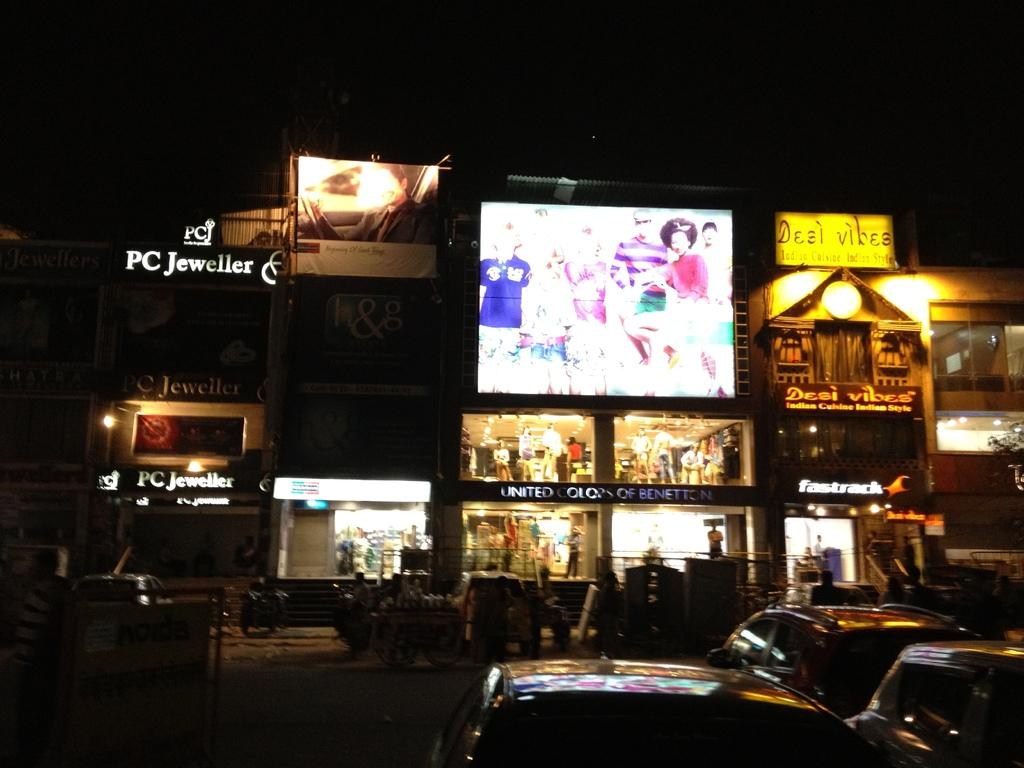<image>
Give a short and clear explanation of the subsequent image. A small group of shops are bightly lit at night including Benneton, PC Jeweller and Desi Vibes 